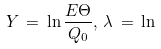Convert formula to latex. <formula><loc_0><loc_0><loc_500><loc_500>Y \, = \, \ln \frac { E \Theta } { Q _ { 0 } } , \, \lambda \, = \, \ln</formula> 